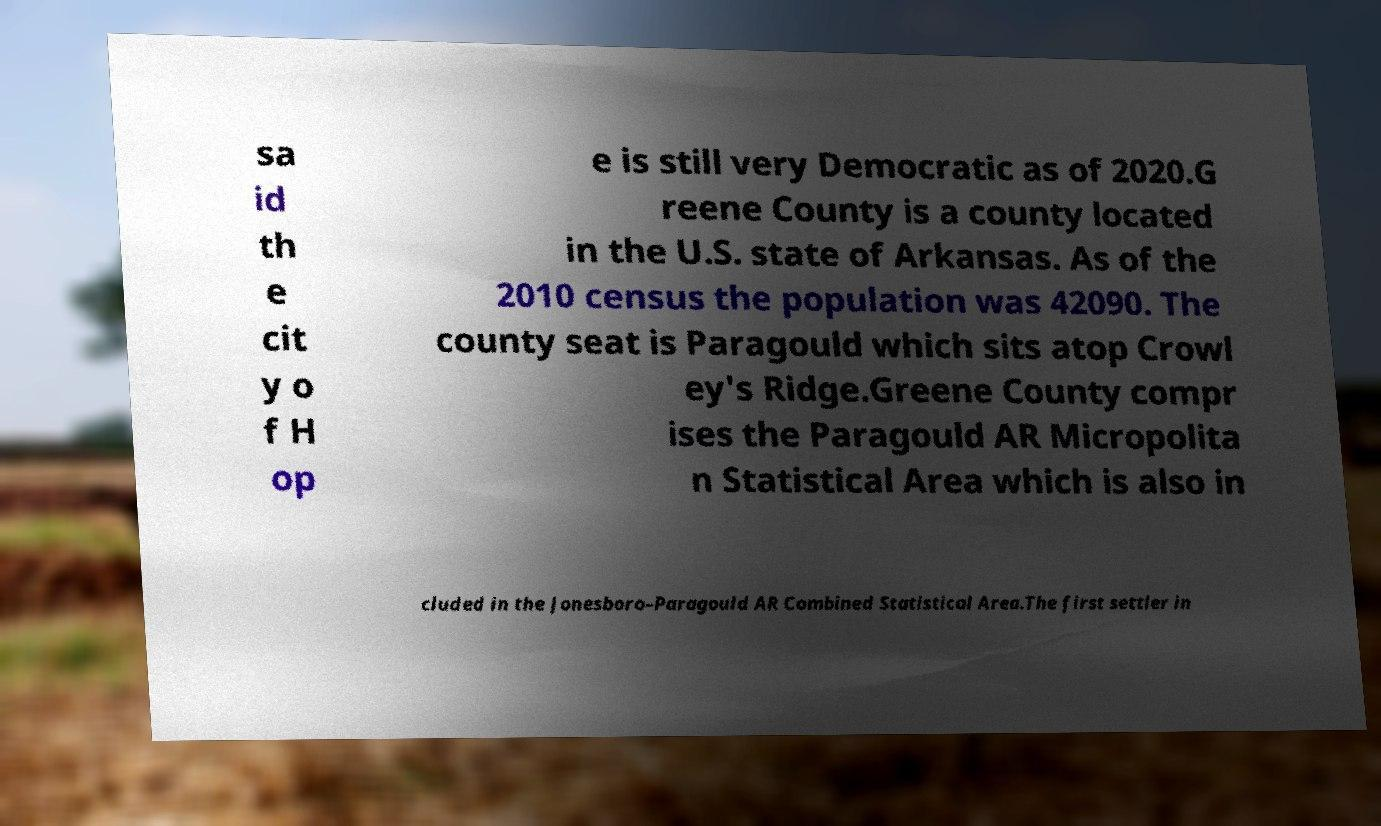Please read and relay the text visible in this image. What does it say? sa id th e cit y o f H op e is still very Democratic as of 2020.G reene County is a county located in the U.S. state of Arkansas. As of the 2010 census the population was 42090. The county seat is Paragould which sits atop Crowl ey's Ridge.Greene County compr ises the Paragould AR Micropolita n Statistical Area which is also in cluded in the Jonesboro–Paragould AR Combined Statistical Area.The first settler in 